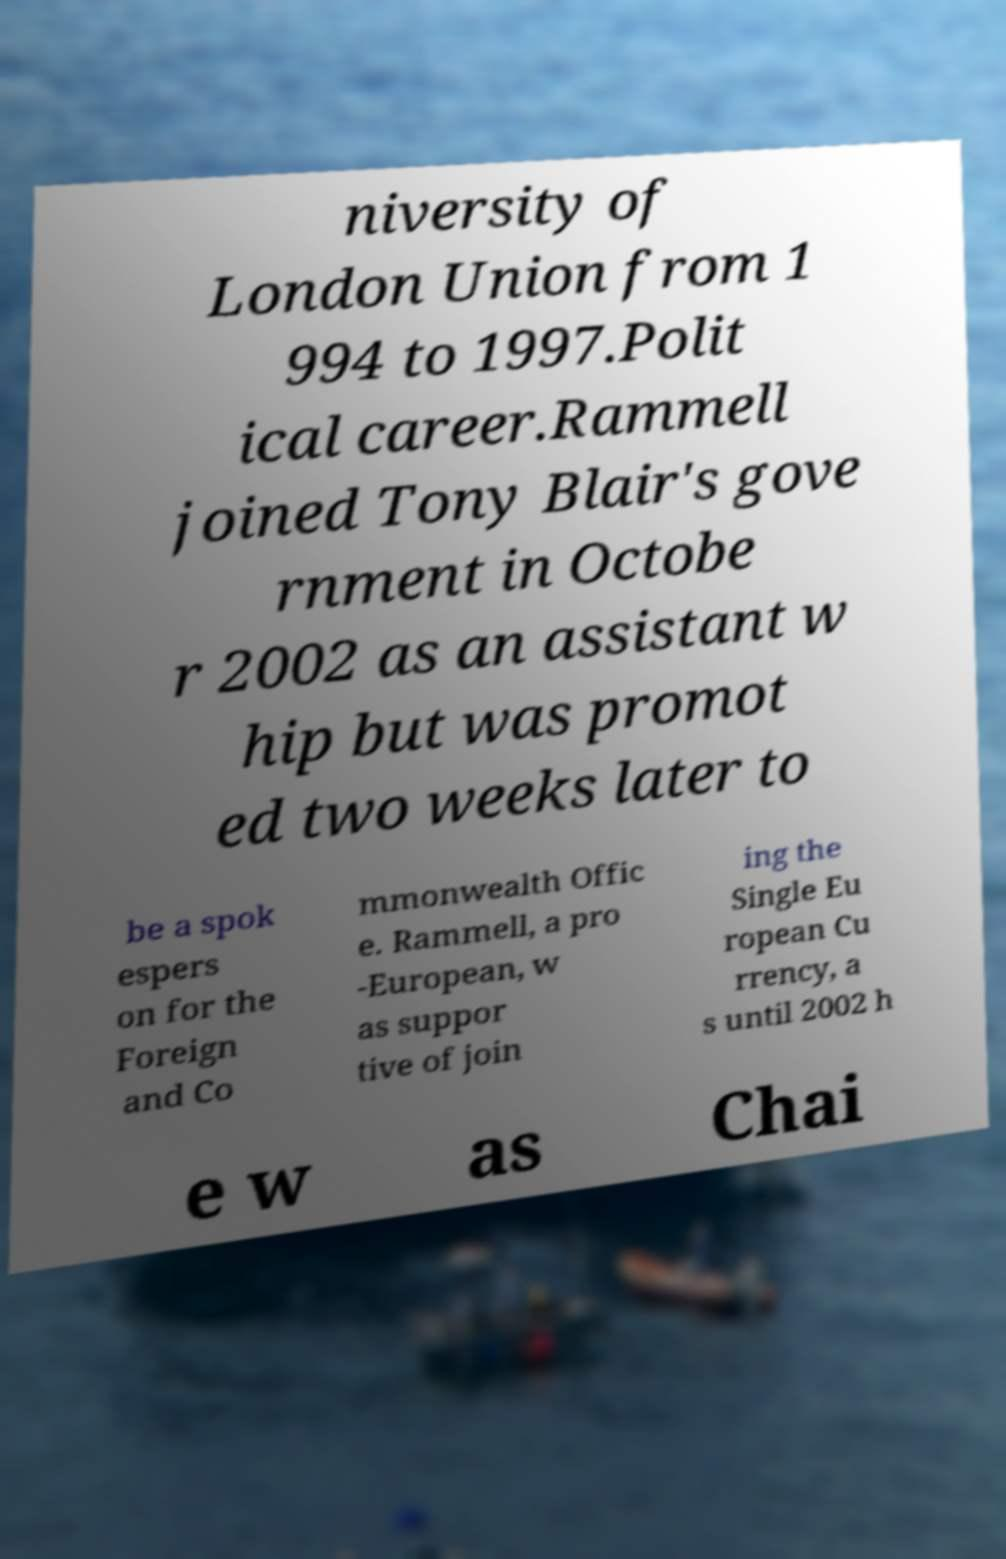Please identify and transcribe the text found in this image. niversity of London Union from 1 994 to 1997.Polit ical career.Rammell joined Tony Blair's gove rnment in Octobe r 2002 as an assistant w hip but was promot ed two weeks later to be a spok espers on for the Foreign and Co mmonwealth Offic e. Rammell, a pro -European, w as suppor tive of join ing the Single Eu ropean Cu rrency, a s until 2002 h e w as Chai 